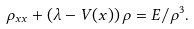<formula> <loc_0><loc_0><loc_500><loc_500>\rho _ { x x } + \left ( \lambda - V ( x ) \right ) \rho = E / \rho ^ { 3 } .</formula> 